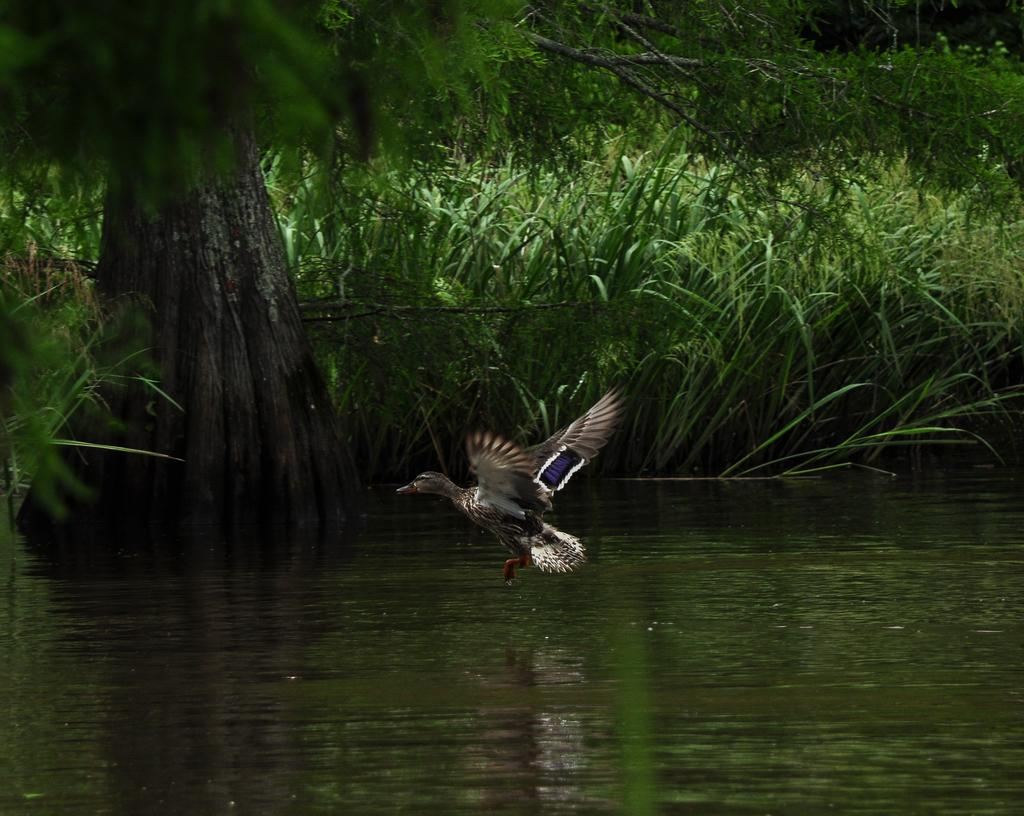What is at the bottom of the image? There is water at the bottom of the image. What is happening in the middle of the image? A bird is flying in the middle of the image. What can be seen on the left side of the image? There is a tree on the left side of the image. What type of vegetation is visible in the background of the image? There are plants visible in the background of the image. What type of soap is the queen using in the image? There is no queen or soap present in the image. What does the bird need to fly in the image? The bird does not need anything to fly in the image; it is already flying. 